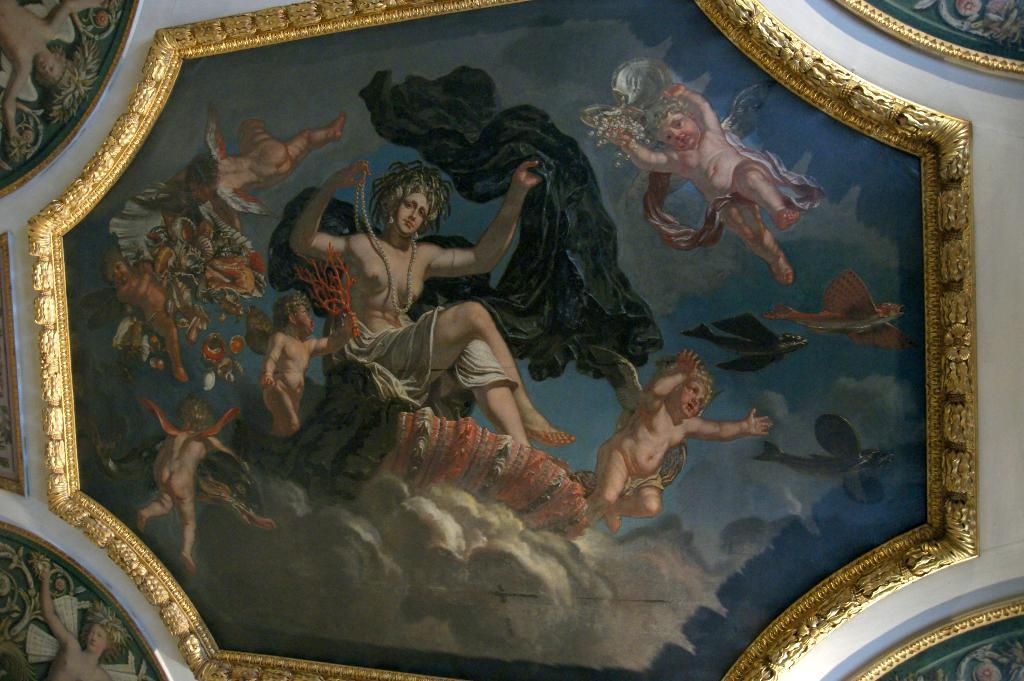Who or what is present in the image? There are people in the image. What is the color of the cloth in the image? There is a black cloth in the image. What can be seen inside the frame? There are objects inside the frame. How would you describe the appearance of the frame? The frame is colorful. Can you tell me how many jewels are on the baby's head in the image? There is no baby or jewel present in the image. 